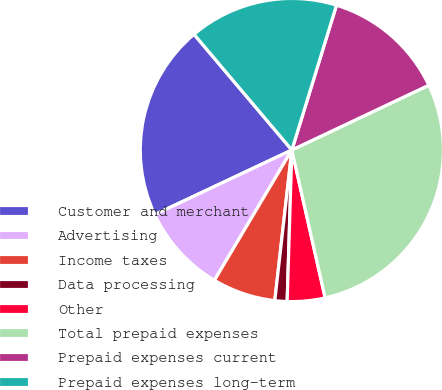Convert chart. <chart><loc_0><loc_0><loc_500><loc_500><pie_chart><fcel>Customer and merchant<fcel>Advertising<fcel>Income taxes<fcel>Data processing<fcel>Other<fcel>Total prepaid expenses<fcel>Prepaid expenses current<fcel>Prepaid expenses long-term<nl><fcel>20.84%<fcel>9.46%<fcel>6.74%<fcel>1.3%<fcel>4.02%<fcel>28.51%<fcel>13.21%<fcel>15.93%<nl></chart> 